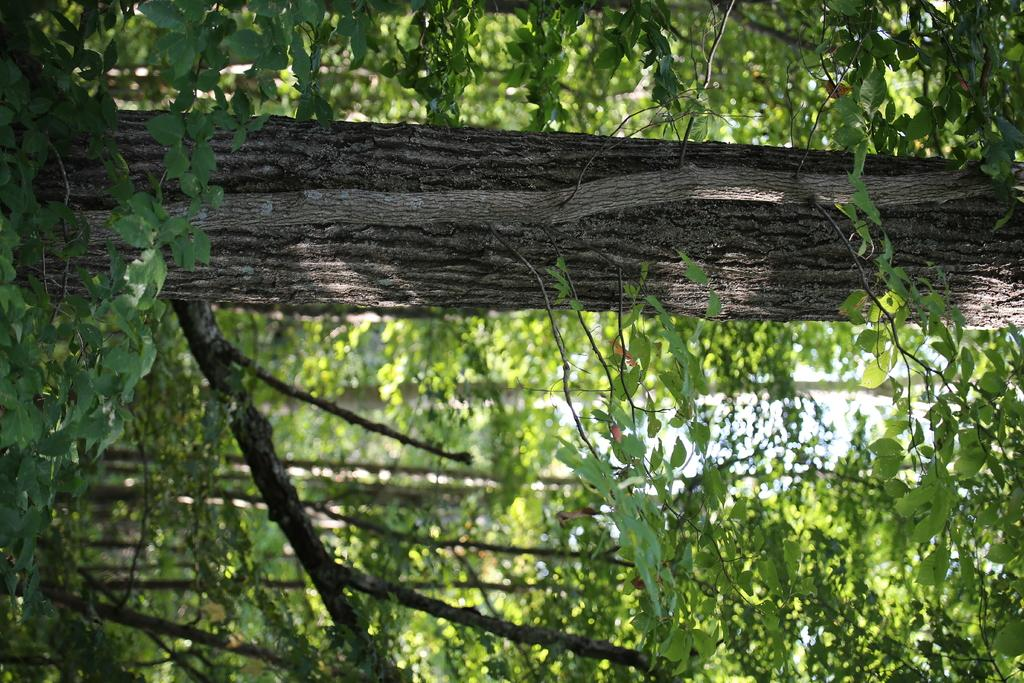What object is located at the top side of the image? There is a trunk at the top side of the image. What type of natural elements can be seen in the image? There are trees in the image. How many ducks are swimming in the trunk in the image? There are no ducks present in the image, and the trunk is not a body of water where ducks would swim. 